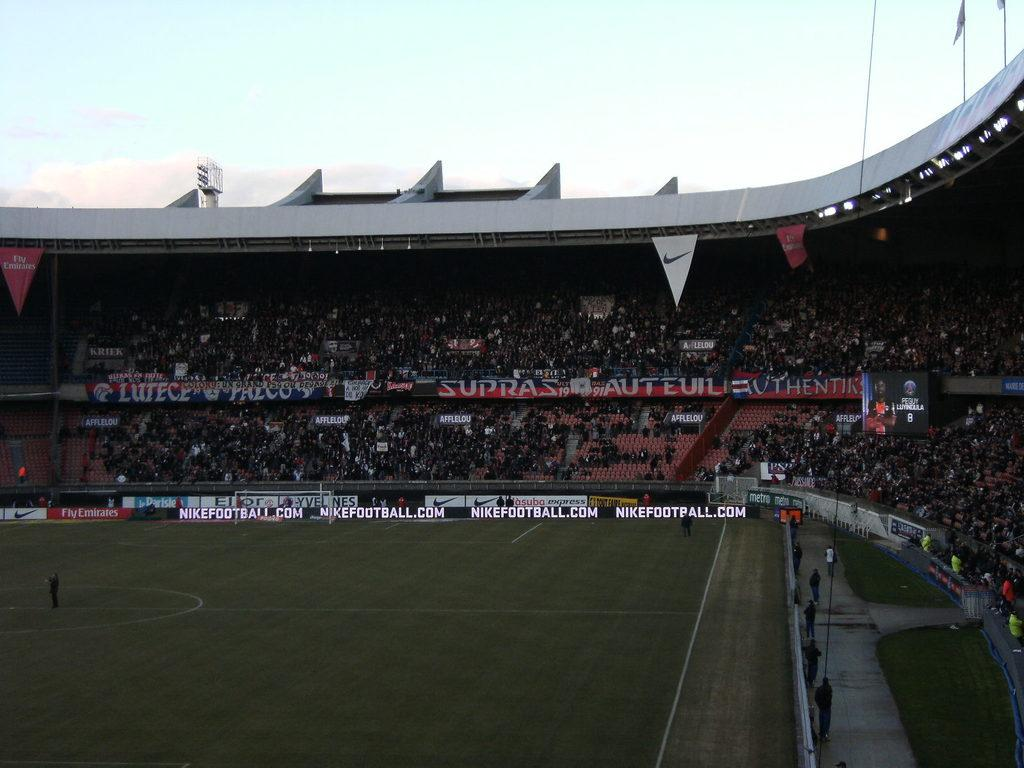<image>
Give a short and clear explanation of the subsequent image. A stadium has nikefootball.com displayed near the edge of the field. 